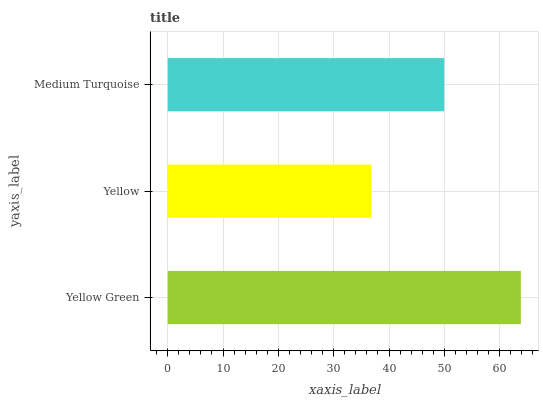Is Yellow the minimum?
Answer yes or no. Yes. Is Yellow Green the maximum?
Answer yes or no. Yes. Is Medium Turquoise the minimum?
Answer yes or no. No. Is Medium Turquoise the maximum?
Answer yes or no. No. Is Medium Turquoise greater than Yellow?
Answer yes or no. Yes. Is Yellow less than Medium Turquoise?
Answer yes or no. Yes. Is Yellow greater than Medium Turquoise?
Answer yes or no. No. Is Medium Turquoise less than Yellow?
Answer yes or no. No. Is Medium Turquoise the high median?
Answer yes or no. Yes. Is Medium Turquoise the low median?
Answer yes or no. Yes. Is Yellow the high median?
Answer yes or no. No. Is Yellow Green the low median?
Answer yes or no. No. 